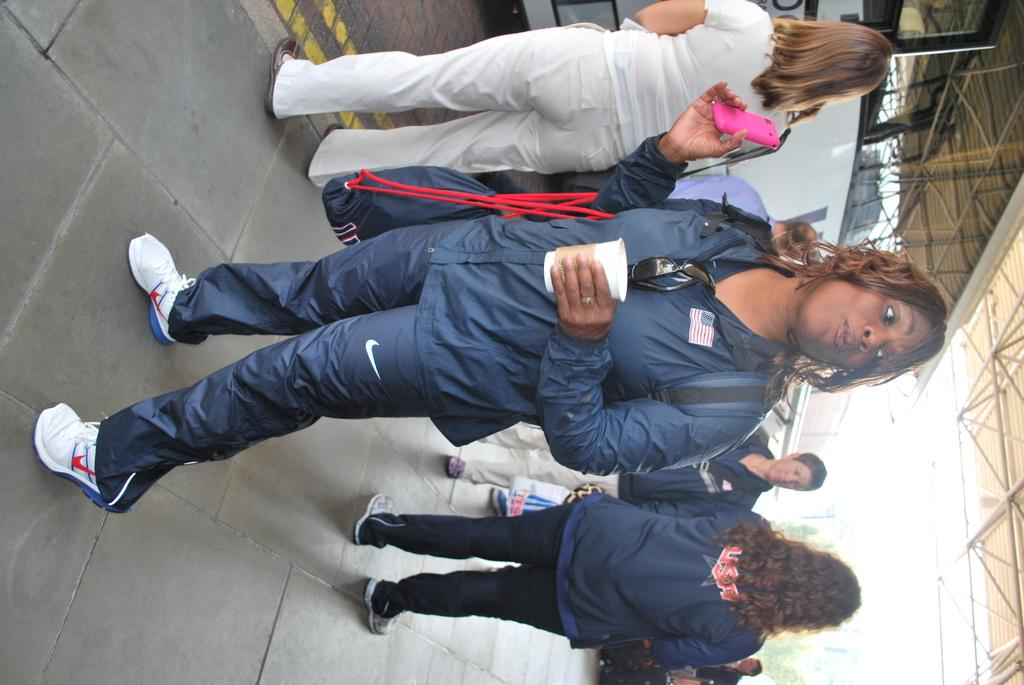What can be seen in the image? There are people standing in the image. Where are the people standing? The people are standing on the floor. What can be seen in the background of the image? There are trees, buildings, grills, and the sky visible in the background of the image. What type of disease is affecting the trees in the image? There is no indication of any disease affecting the trees in the image; they appear healthy. 